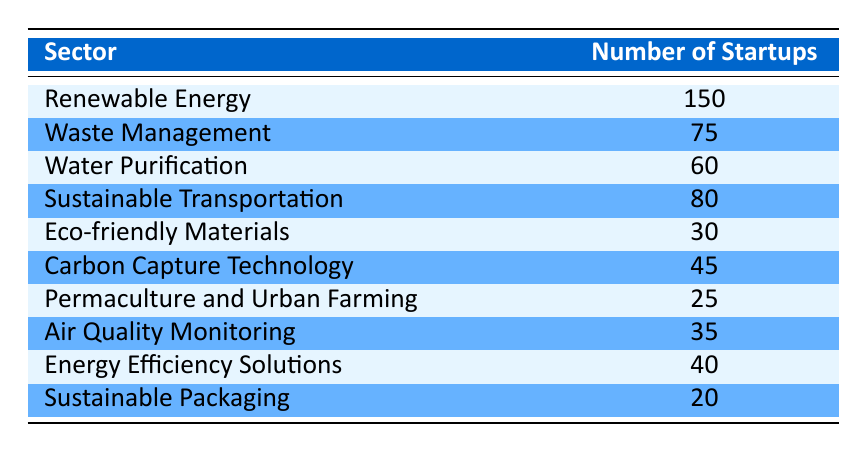What is the sector with the highest number of startups? The table lists various sectors along with their corresponding number of startups. By looking through the "Number of Startups" column, we can see that "Renewable Energy" has the highest number at 150.
Answer: Renewable Energy How many startups are focused on Waste Management? Directly from the table, the "Waste Management" sector shows a total of 75 startups listed under it.
Answer: 75 What is the combined number of startups in the sectors of Water Purification and Sustainable Transportation? To find this, we add the number of startups in "Water Purification" (60) and "Sustainable Transportation" (80). So, 60 + 80 = 140.
Answer: 140 Is there a sector with fewer than 30 startups? Upon examining the table, we see that the "Permaculture and Urban Farming" sector has only 25 startups, which is fewer than 30.
Answer: Yes What is the average number of startups across all listed sectors? First, we must sum the number of startups for each sector: 150 + 75 + 60 + 80 + 30 + 45 + 25 + 35 + 40 + 20 = 620. There are 10 sectors in total, so the average is 620 / 10 = 62.
Answer: 62 What are the two sectors with the least number of startups? The table indicates that "Sustainable Packaging" has 20 startups, and "Permaculture and Urban Farming" has 25 startups, making them the two sectors with the least number of startups.
Answer: Sustainable Packaging and Permaculture and Urban Farming How many more startups are in the Renewable Energy sector compared to the Eco-friendly Materials sector? We can find this by subtracting the number of startups in "Eco-friendly Materials" (30) from "Renewable Energy" (150). Thus, 150 - 30 = 120 more startups in Renewable Energy.
Answer: 120 What percentage of the total number of startups are in Sustainable Transportation? First, we calculated the total number of startups (620). Then we find the proportion for "Sustainable Transportation," which has 80 startups. The percentage is (80 / 620) * 100, which equals approximately 12.9%.
Answer: 12.9% 